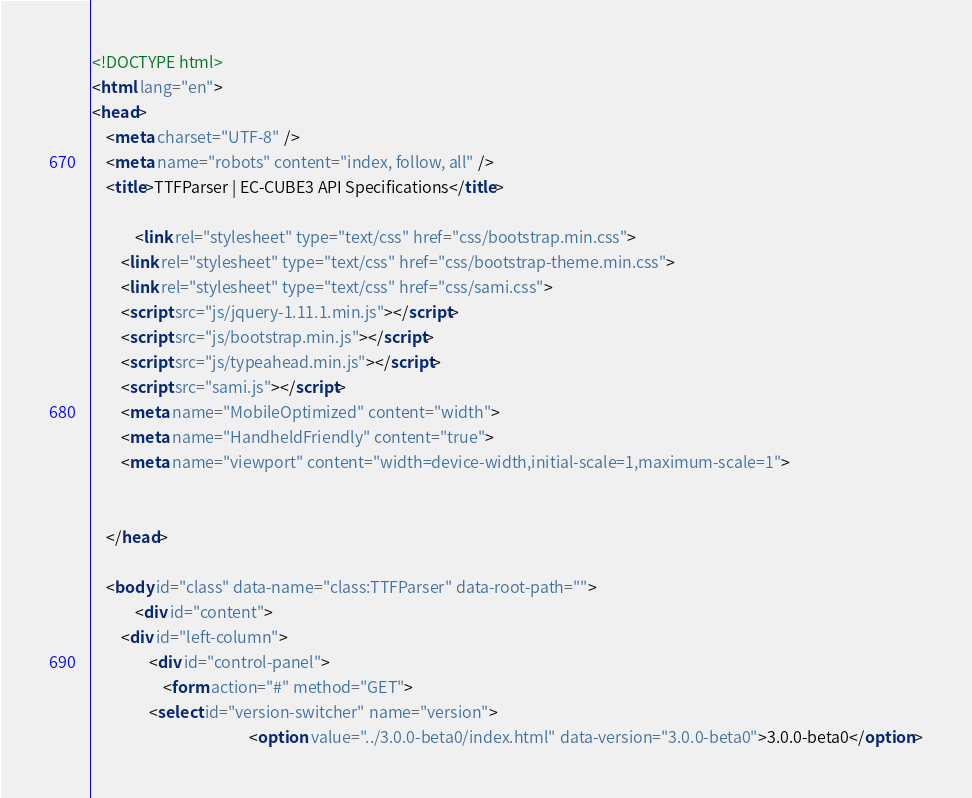Convert code to text. <code><loc_0><loc_0><loc_500><loc_500><_HTML_><!DOCTYPE html>
<html lang="en">
<head>
    <meta charset="UTF-8" />
    <meta name="robots" content="index, follow, all" />
    <title>TTFParser | EC-CUBE3 API Specifications</title>

            <link rel="stylesheet" type="text/css" href="css/bootstrap.min.css">
        <link rel="stylesheet" type="text/css" href="css/bootstrap-theme.min.css">
        <link rel="stylesheet" type="text/css" href="css/sami.css">
        <script src="js/jquery-1.11.1.min.js"></script>
        <script src="js/bootstrap.min.js"></script>
        <script src="js/typeahead.min.js"></script>
        <script src="sami.js"></script>
        <meta name="MobileOptimized" content="width">
        <meta name="HandheldFriendly" content="true">
        <meta name="viewport" content="width=device-width,initial-scale=1,maximum-scale=1">
    
    
    </head>

    <body id="class" data-name="class:TTFParser" data-root-path="">
            <div id="content">
        <div id="left-column">
                <div id="control-panel">
                    <form action="#" method="GET">
                <select id="version-switcher" name="version">
                                            <option value="../3.0.0-beta0/index.html" data-version="3.0.0-beta0">3.0.0-beta0</option></code> 